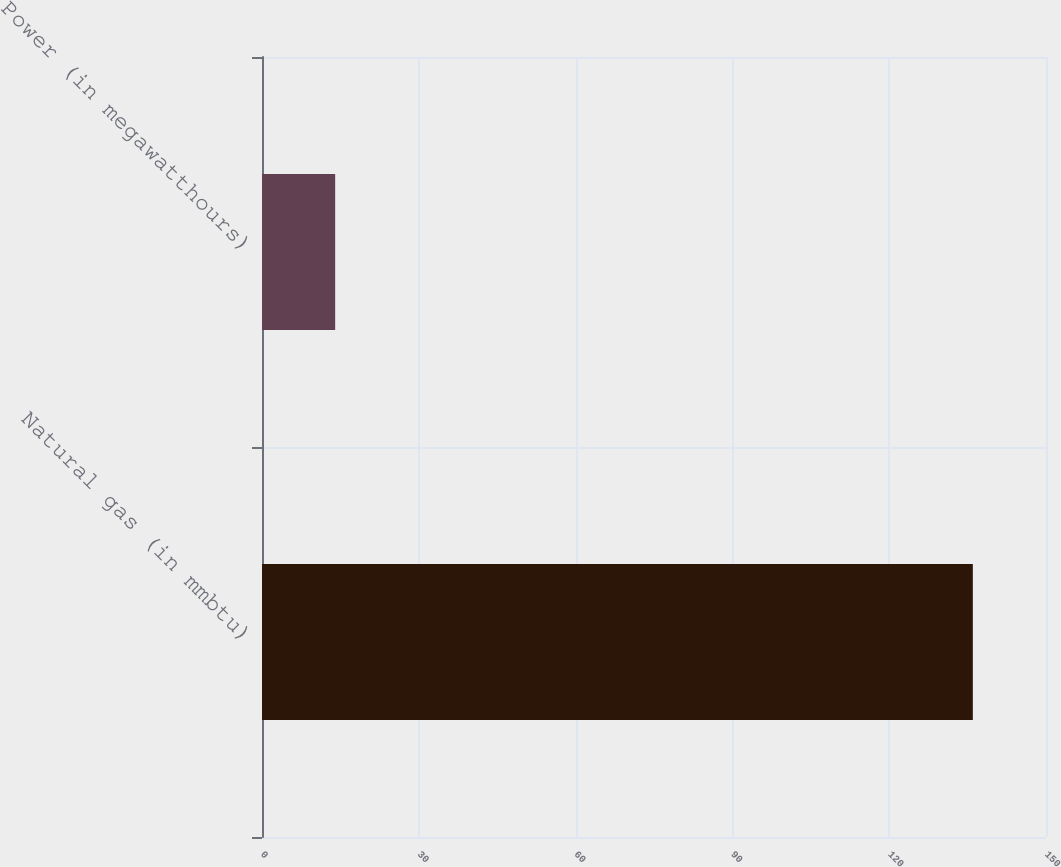<chart> <loc_0><loc_0><loc_500><loc_500><bar_chart><fcel>Natural gas (in mmbtu)<fcel>Power (in megawatthours)<nl><fcel>136<fcel>14<nl></chart> 